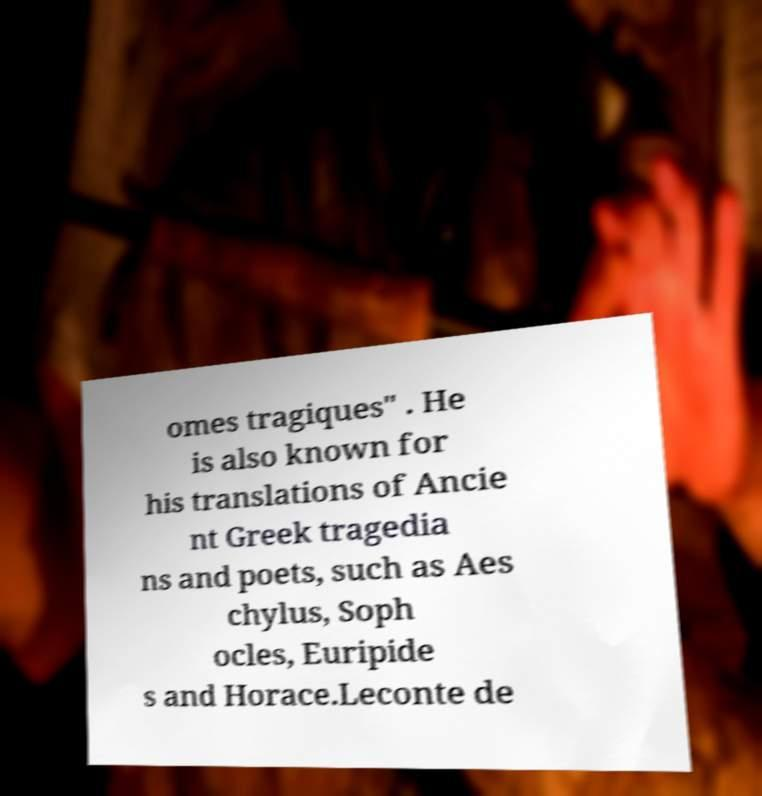There's text embedded in this image that I need extracted. Can you transcribe it verbatim? omes tragiques" . He is also known for his translations of Ancie nt Greek tragedia ns and poets, such as Aes chylus, Soph ocles, Euripide s and Horace.Leconte de 